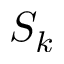<formula> <loc_0><loc_0><loc_500><loc_500>S _ { k }</formula> 